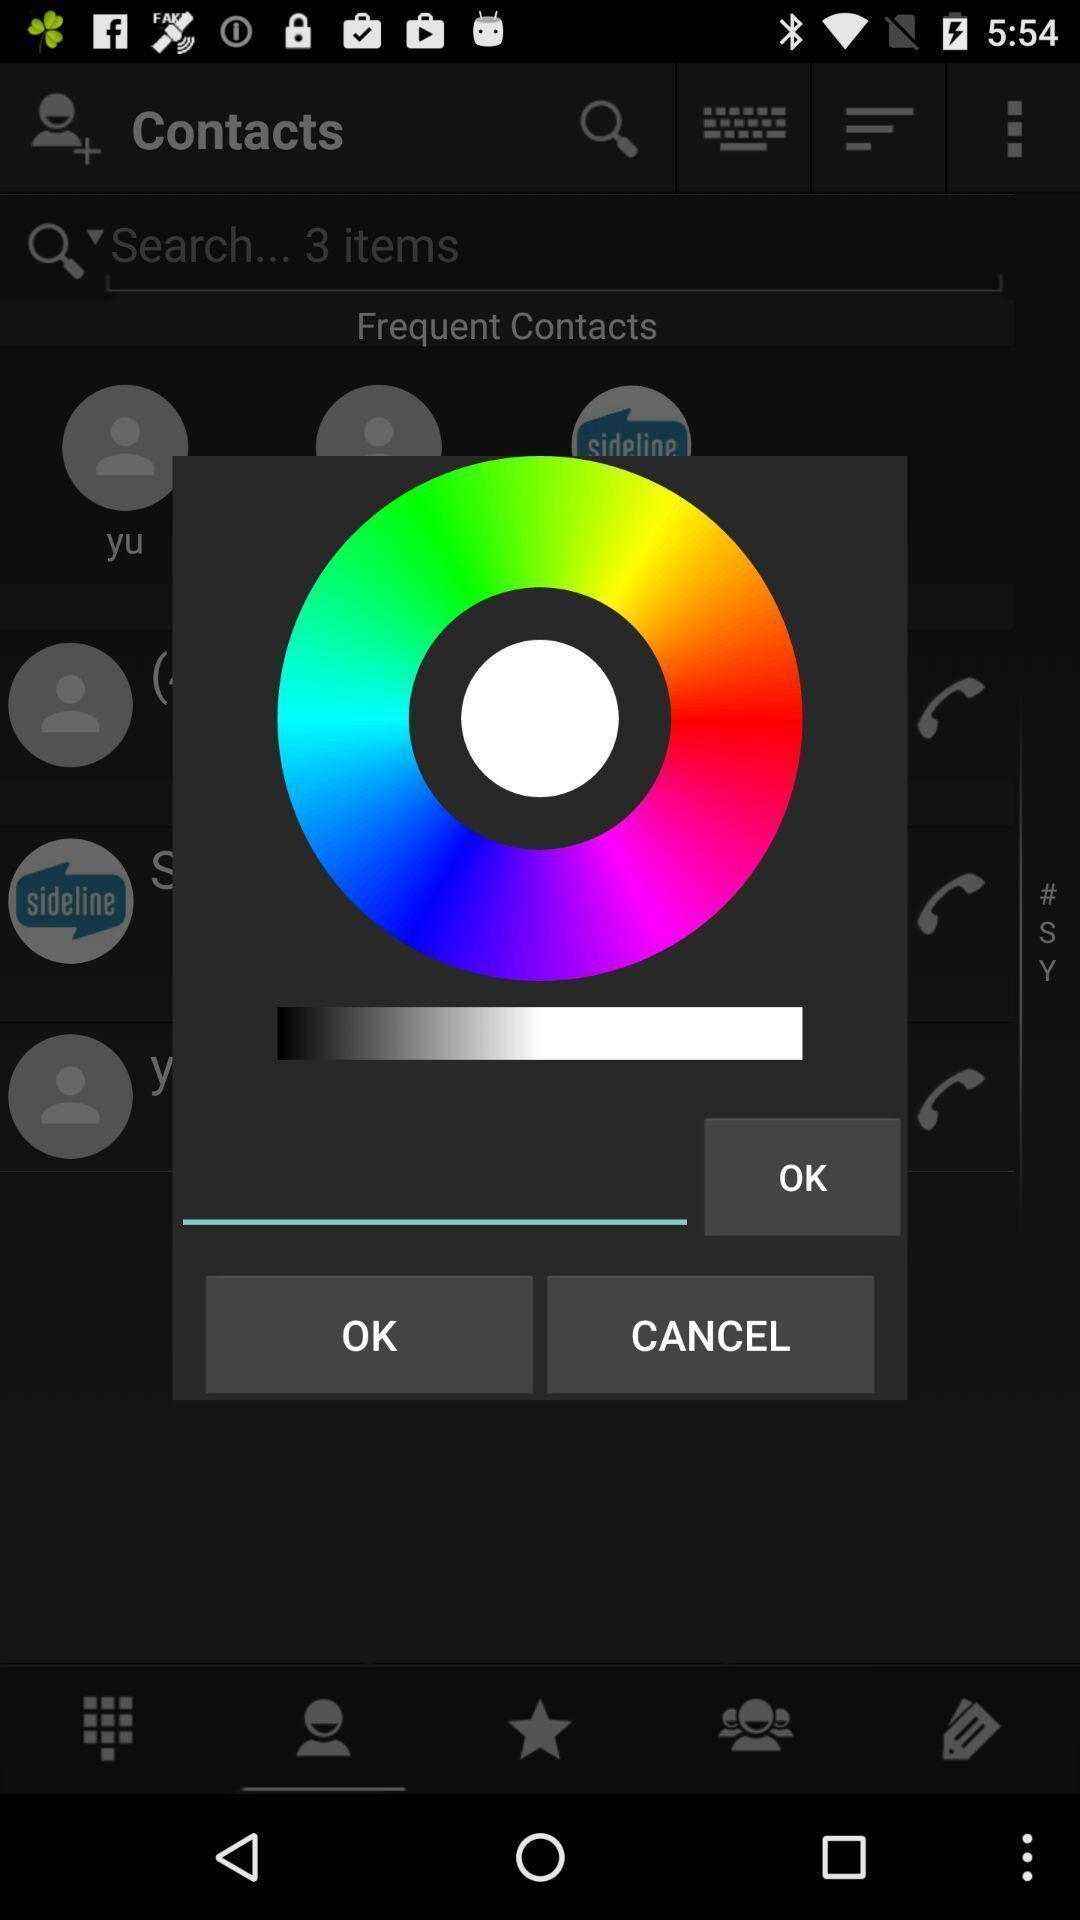Please provide a description for this image. Pop-up shows colors circle. 